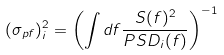<formula> <loc_0><loc_0><loc_500><loc_500>( \sigma _ { p f } ) ^ { 2 } _ { i } = \left ( \int d f \frac { S ( f ) ^ { 2 } } { P S D _ { i } ( f ) } \right ) ^ { - 1 }</formula> 